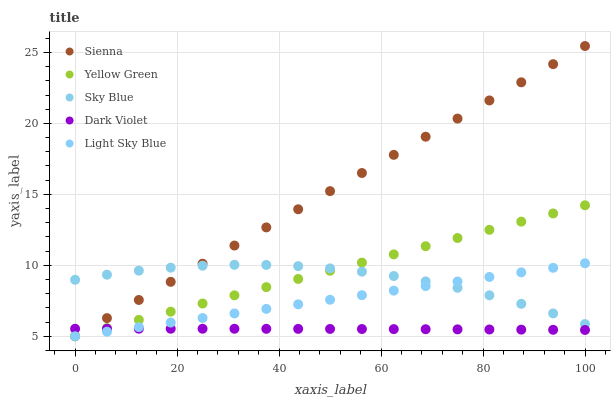Does Dark Violet have the minimum area under the curve?
Answer yes or no. Yes. Does Sienna have the maximum area under the curve?
Answer yes or no. Yes. Does Sky Blue have the minimum area under the curve?
Answer yes or no. No. Does Sky Blue have the maximum area under the curve?
Answer yes or no. No. Is Yellow Green the smoothest?
Answer yes or no. Yes. Is Sky Blue the roughest?
Answer yes or no. Yes. Is Light Sky Blue the smoothest?
Answer yes or no. No. Is Light Sky Blue the roughest?
Answer yes or no. No. Does Sienna have the lowest value?
Answer yes or no. Yes. Does Sky Blue have the lowest value?
Answer yes or no. No. Does Sienna have the highest value?
Answer yes or no. Yes. Does Sky Blue have the highest value?
Answer yes or no. No. Is Dark Violet less than Sky Blue?
Answer yes or no. Yes. Is Sky Blue greater than Dark Violet?
Answer yes or no. Yes. Does Dark Violet intersect Sienna?
Answer yes or no. Yes. Is Dark Violet less than Sienna?
Answer yes or no. No. Is Dark Violet greater than Sienna?
Answer yes or no. No. Does Dark Violet intersect Sky Blue?
Answer yes or no. No. 